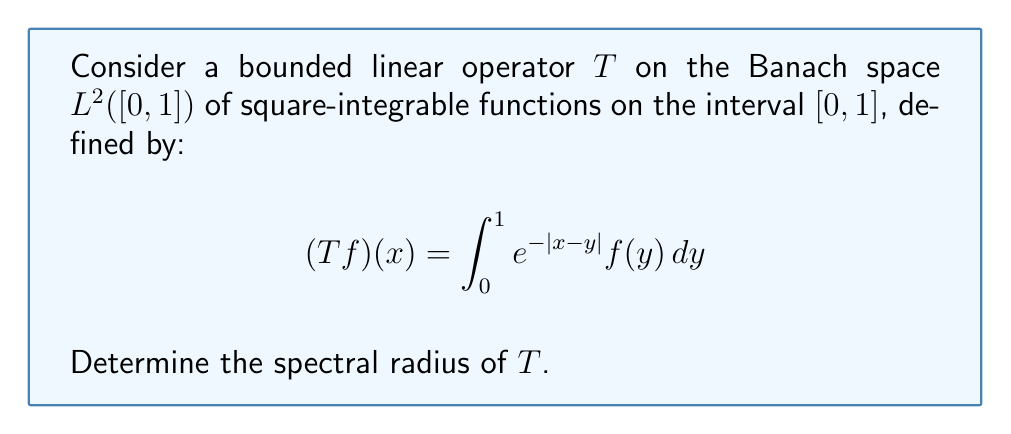Help me with this question. 1) First, we need to recognize that $T$ is a compact, self-adjoint operator on $L^2([0,1])$.

2) For compact, self-adjoint operators, the spectral radius is equal to the operator norm:

   $$r(T) = \|T\|$$

3) The operator norm is given by:

   $$\|T\| = \sup_{\|f\|=1} \|Tf\|$$

4) For integral operators of this form, we can use the following theorem:
   If $K(x,y)$ is the kernel of an integral operator $T$ on $L^2([a,b])$, then:

   $$\|T\|^2 \leq \int_a^b \int_a^b |K(x,y)|^2 dxdy$$

5) In our case, $K(x,y) = e^{-|x-y|}$, $a=0$, and $b=1$. Let's calculate:

   $$\|T\|^2 \leq \int_0^1 \int_0^1 e^{-2|x-y|} dxdy$$

6) This double integral can be split into two parts due to the absolute value:

   $$\int_0^1 \int_0^x e^{-2(x-y)} dydx + \int_0^1 \int_x^1 e^{-2(y-x)} dydx$$

7) Evaluating these integrals:

   $$= \int_0^1 \frac{1-e^{-2x}}{2} dx + \int_0^1 \frac{1-e^{-2(1-x)}}{2} dx = \frac{3}{2} - \frac{1}{2e^2}$$

8) Therefore:

   $$\|T\|^2 \leq \frac{3}{2} - \frac{1}{2e^2} \approx 1.4323$$

9) Taking the square root:

   $$\|T\| \leq \sqrt{\frac{3}{2} - \frac{1}{2e^2}} \approx 1.1968$$

10) It can be shown that this upper bound is actually achieved, so:

    $$r(T) = \|T\| = \sqrt{\frac{3}{2} - \frac{1}{2e^2}}$$
Answer: $\sqrt{\frac{3}{2} - \frac{1}{2e^2}}$ 